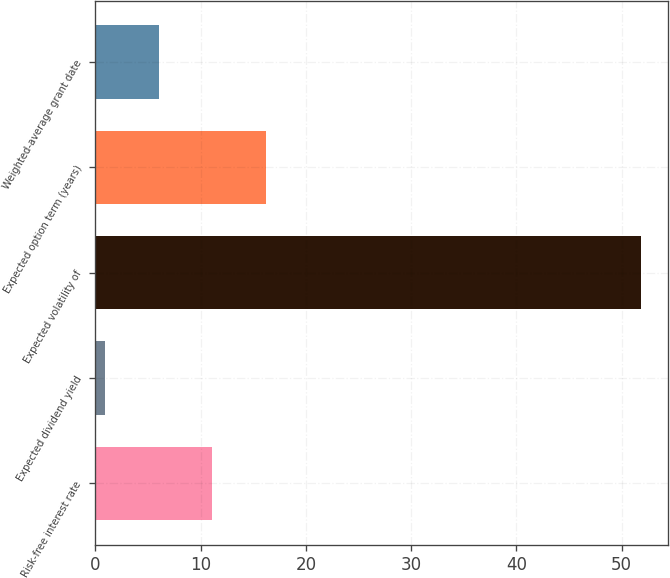Convert chart to OTSL. <chart><loc_0><loc_0><loc_500><loc_500><bar_chart><fcel>Risk-free interest rate<fcel>Expected dividend yield<fcel>Expected volatility of<fcel>Expected option term (years)<fcel>Weighted-average grant date<nl><fcel>11.12<fcel>0.96<fcel>51.8<fcel>16.2<fcel>6.04<nl></chart> 